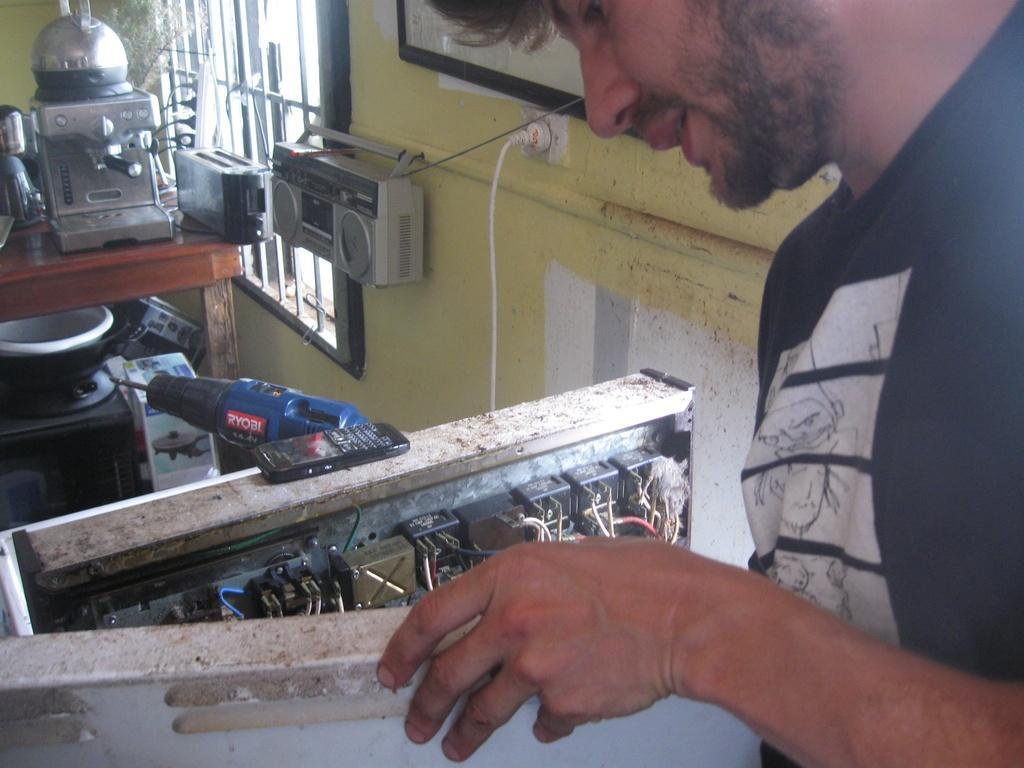Can you describe this image briefly? In this image I can see the person wearing the black and white color dress. In-front of the person I can see many electronic gadgets, box and few more objects. In the background I can see the window, frame and the switch board to the wall. 